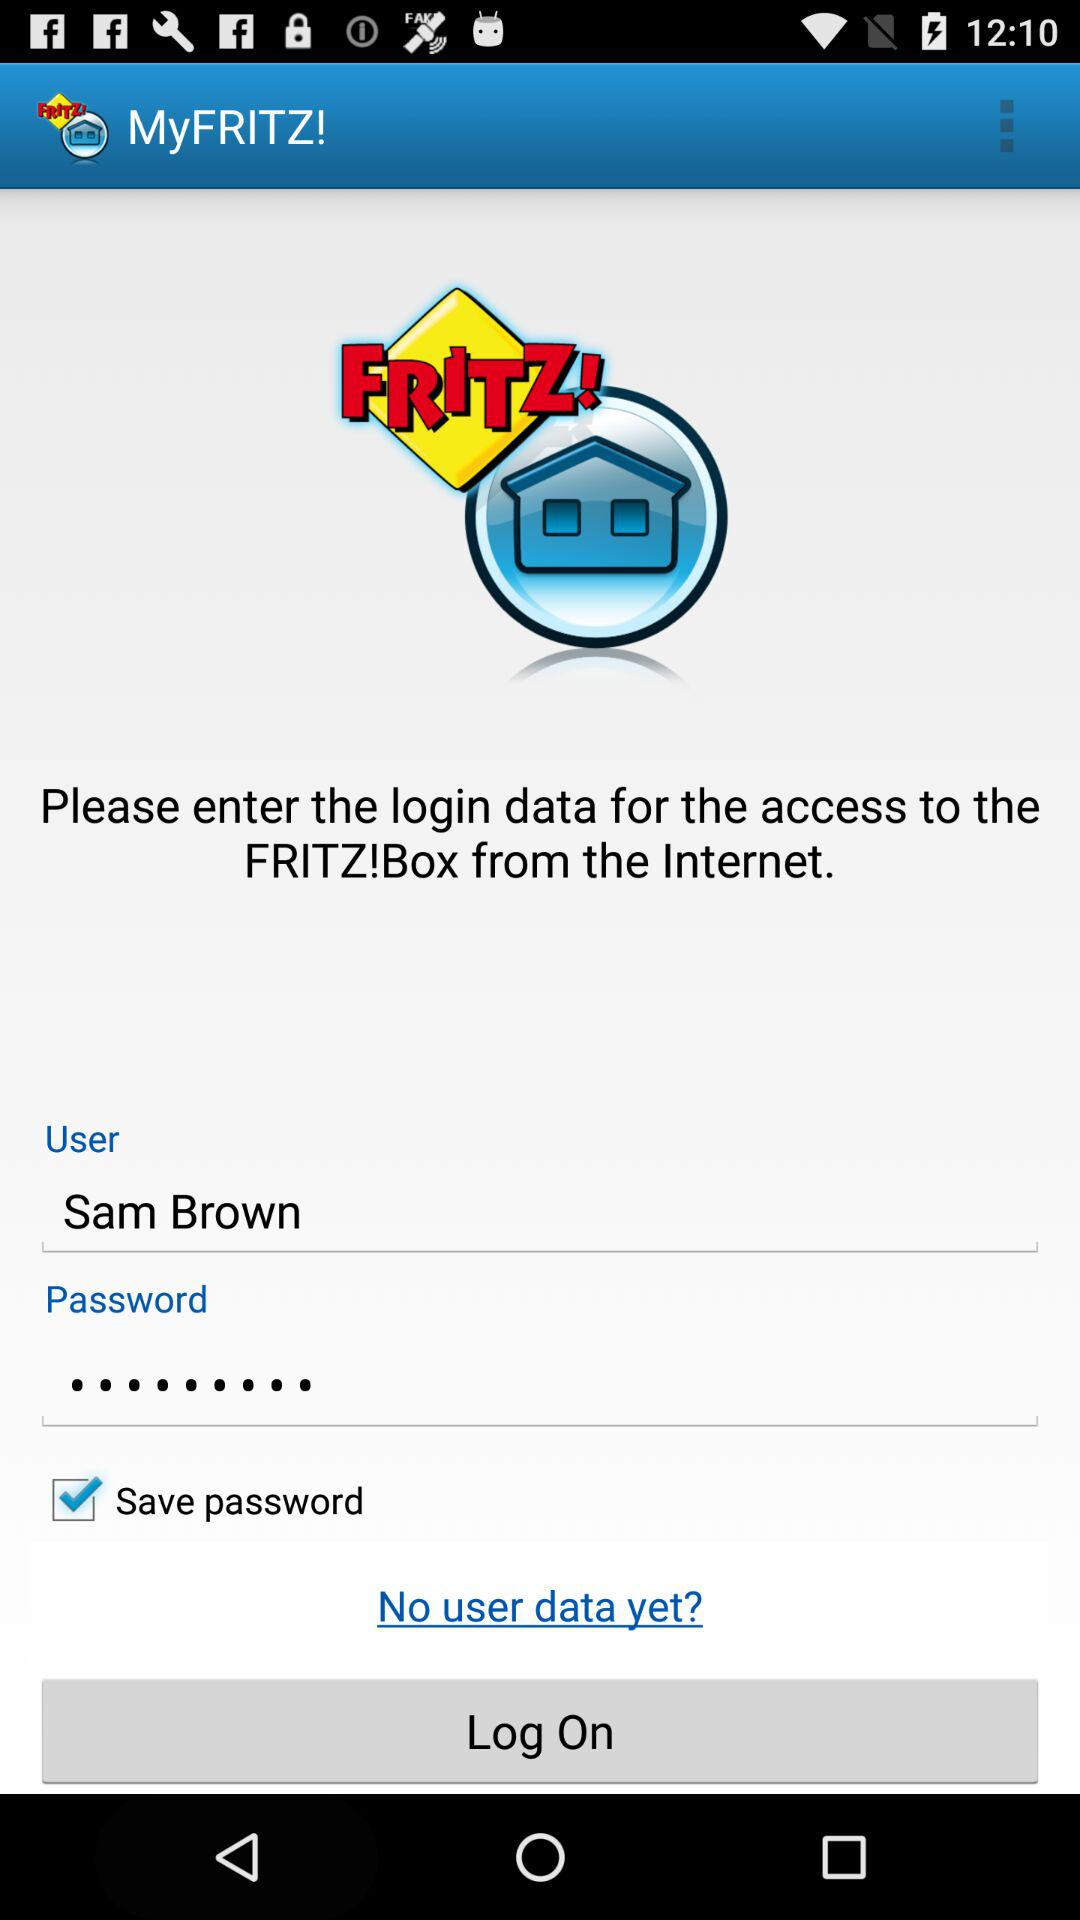How many login fields are there?
Answer the question using a single word or phrase. 2 